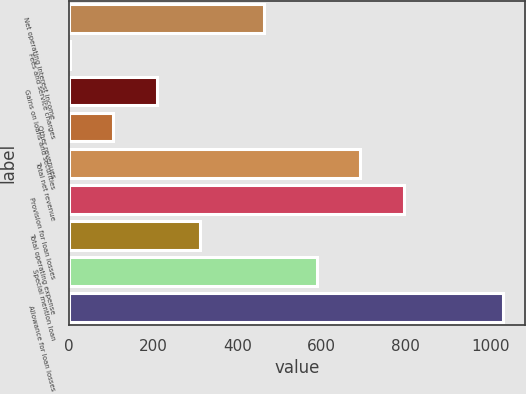Convert chart to OTSL. <chart><loc_0><loc_0><loc_500><loc_500><bar_chart><fcel>Net operating interest income<fcel>Fees and service charges<fcel>Gains on loans and securities<fcel>Other revenues<fcel>Total net revenue<fcel>Provision for loan losses<fcel>Total operating expense<fcel>Special mention loan<fcel>Allowance for loan losses<nl><fcel>463.3<fcel>3.2<fcel>208.8<fcel>106<fcel>692.2<fcel>795<fcel>311.6<fcel>589.4<fcel>1031.2<nl></chart> 